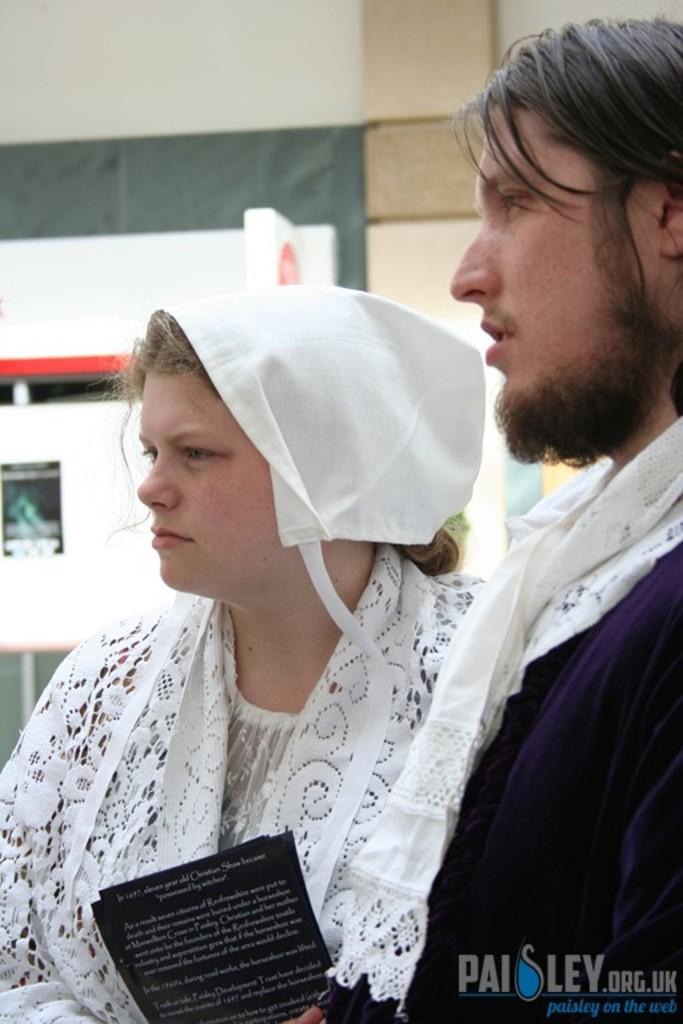Describe this image in one or two sentences. There is a woman wearing white dress is standing and holding an object in her hand and there is another person standing beside her. 